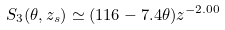<formula> <loc_0><loc_0><loc_500><loc_500>S _ { 3 } ( \theta , z _ { s } ) \simeq ( 1 1 6 - 7 . 4 \theta ) z ^ { - 2 . 0 0 }</formula> 